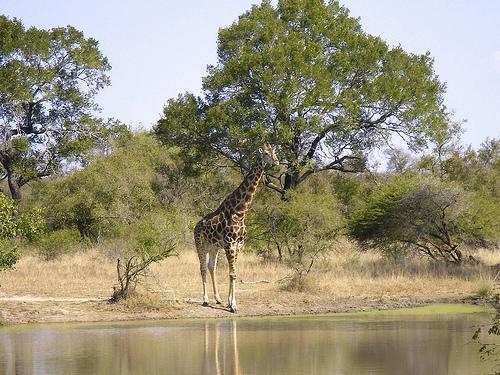How many giraffes are there?
Give a very brief answer. 1. 